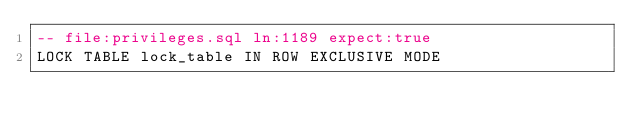<code> <loc_0><loc_0><loc_500><loc_500><_SQL_>-- file:privileges.sql ln:1189 expect:true
LOCK TABLE lock_table IN ROW EXCLUSIVE MODE
</code> 